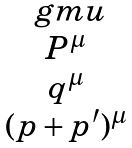<formula> <loc_0><loc_0><loc_500><loc_500>\begin{matrix} \ g m u \\ P ^ { \mu } \\ q ^ { \mu } \\ ( p + p ^ { \prime } ) ^ { \mu } \end{matrix}</formula> 